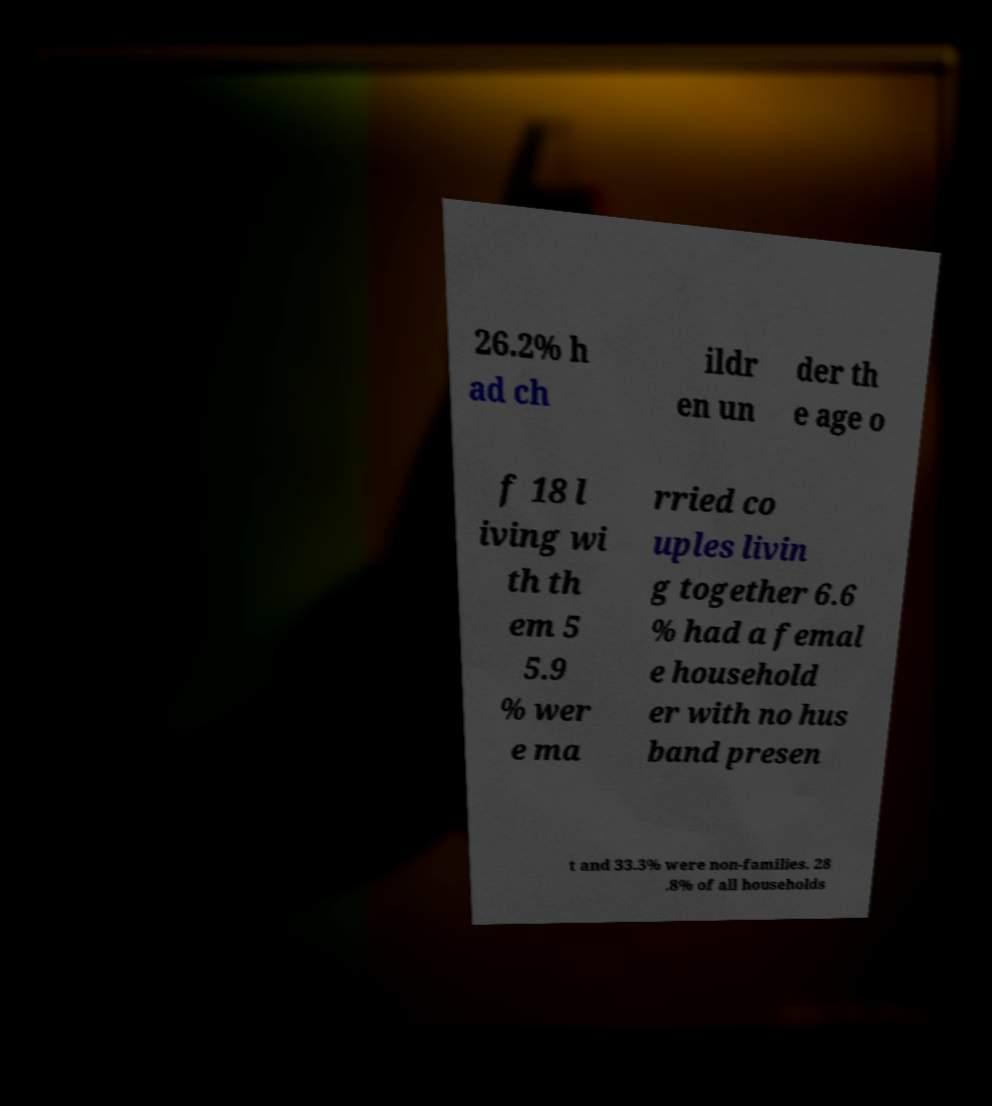There's text embedded in this image that I need extracted. Can you transcribe it verbatim? 26.2% h ad ch ildr en un der th e age o f 18 l iving wi th th em 5 5.9 % wer e ma rried co uples livin g together 6.6 % had a femal e household er with no hus band presen t and 33.3% were non-families. 28 .8% of all households 